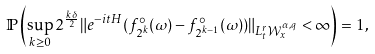<formula> <loc_0><loc_0><loc_500><loc_500>\mathbb { P } \left ( \sup _ { k \geq 0 } 2 ^ { \frac { k \delta } { 2 } } \| e ^ { - i t H } ( f _ { 2 ^ { k } } ^ { \circ } ( \omega ) - f _ { 2 ^ { k - 1 } } ^ { \circ } ( \omega ) ) \| _ { L _ { t } ^ { r } \mathcal { W } _ { x } ^ { \alpha , q } } < \infty \right ) = 1 ,</formula> 